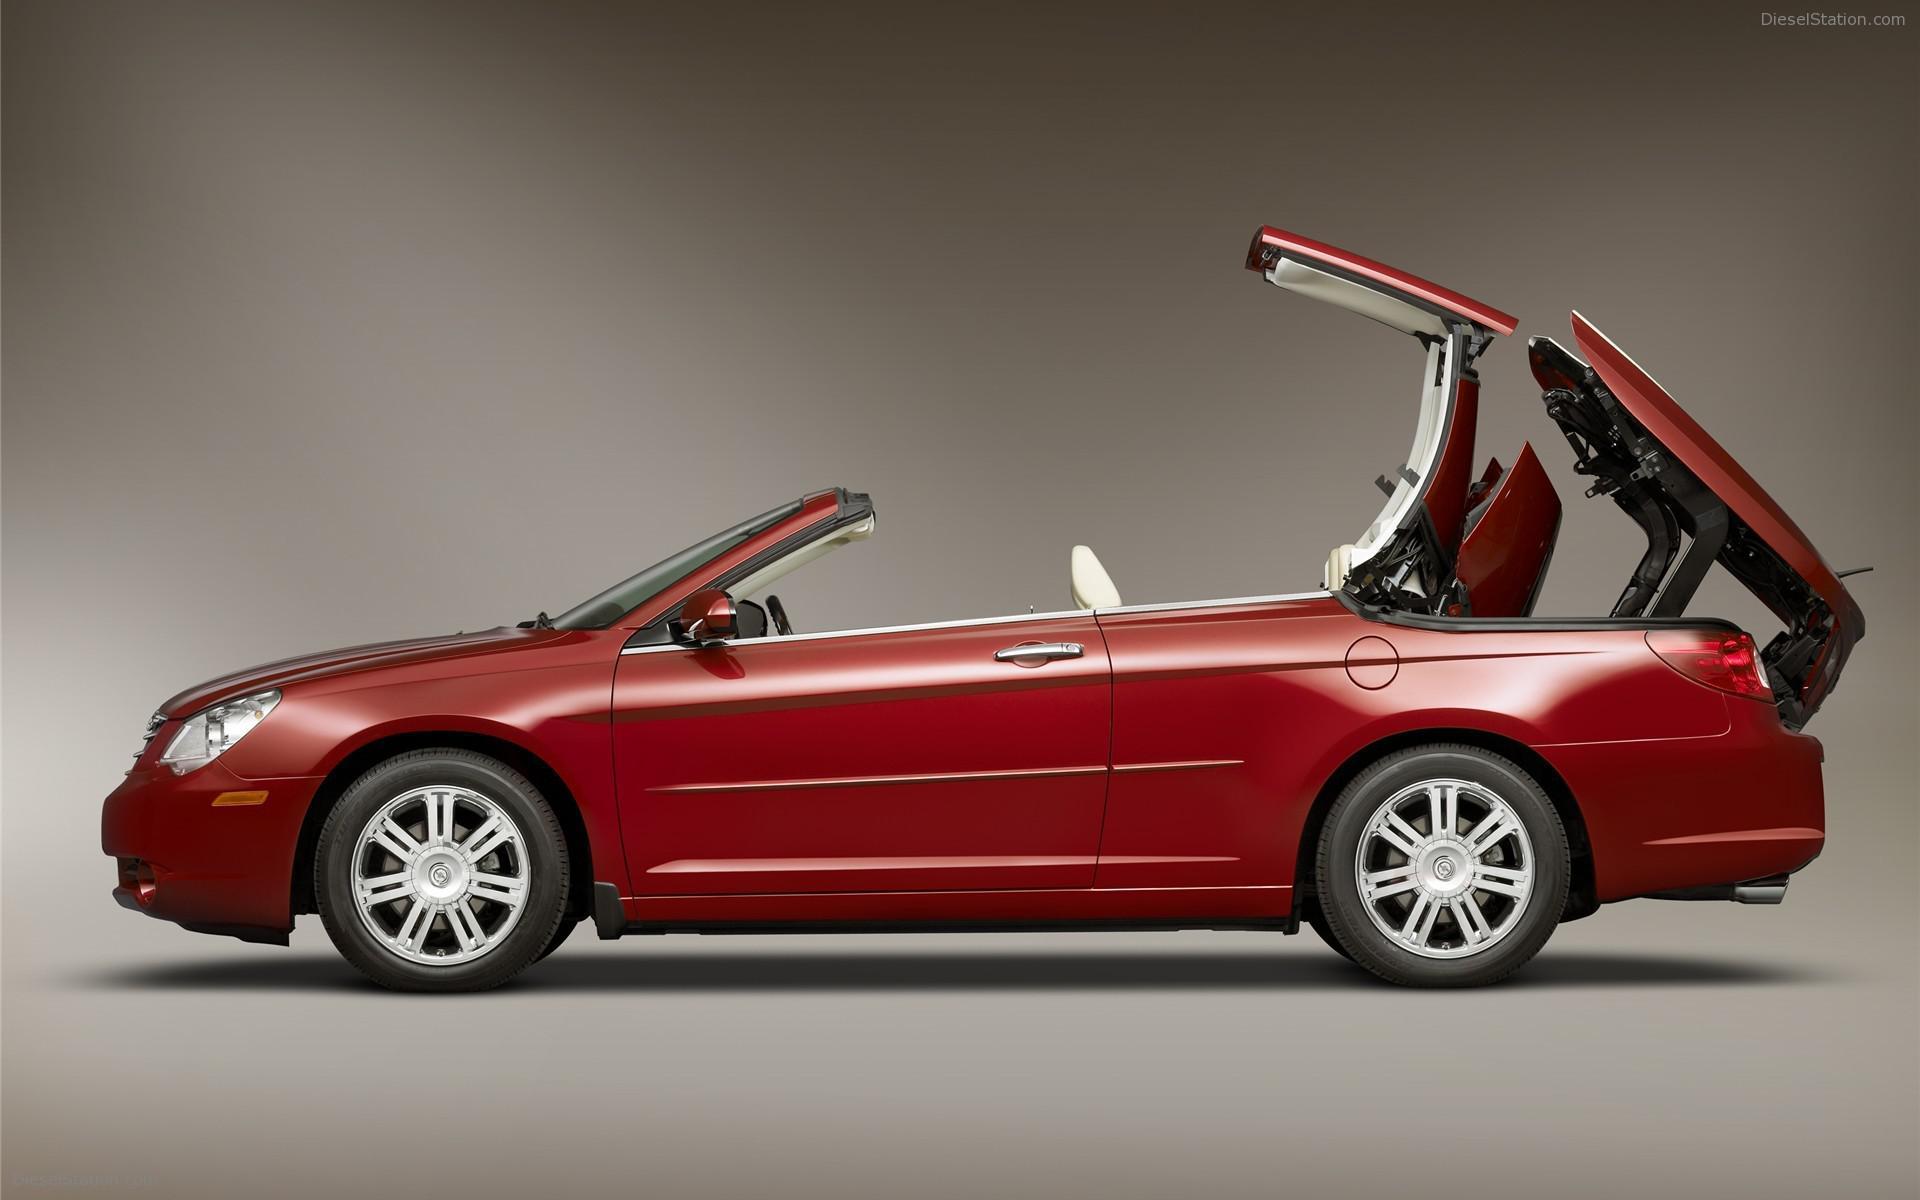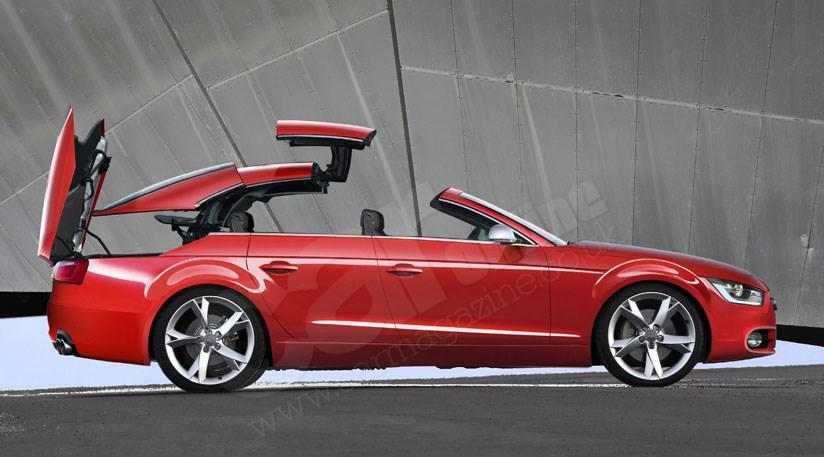The first image is the image on the left, the second image is the image on the right. Analyze the images presented: Is the assertion "Both images contain a red convertible automobile." valid? Answer yes or no. Yes. 